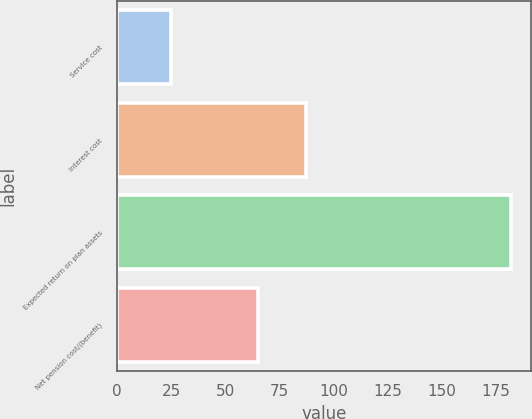Convert chart to OTSL. <chart><loc_0><loc_0><loc_500><loc_500><bar_chart><fcel>Service cost<fcel>Interest cost<fcel>Expected return on plan assets<fcel>Net pension cost/(benefit)<nl><fcel>25<fcel>87<fcel>182<fcel>65<nl></chart> 